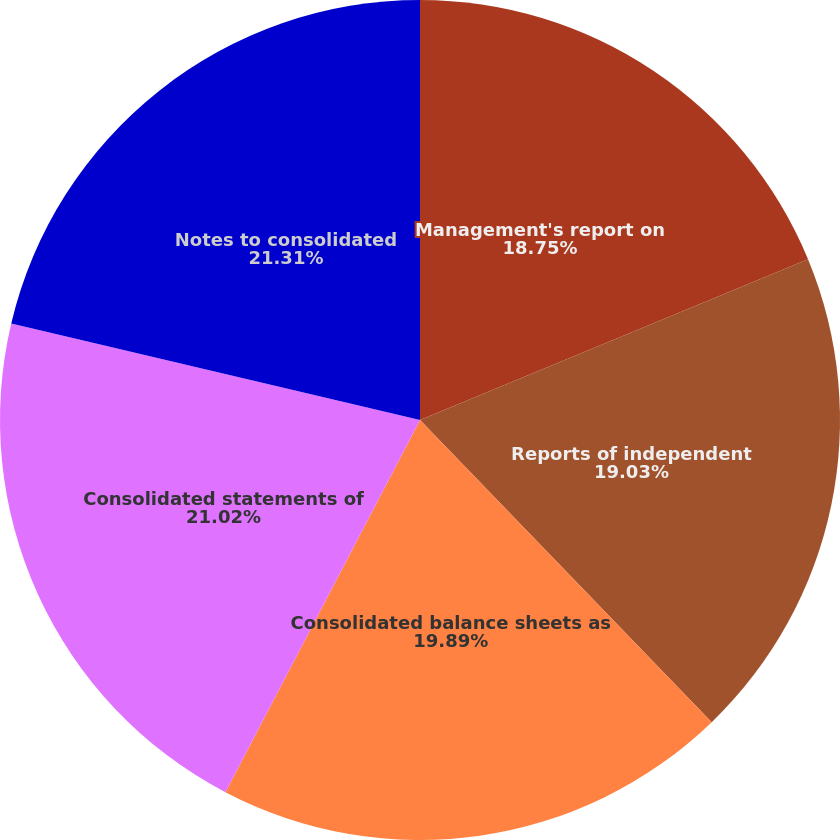Convert chart to OTSL. <chart><loc_0><loc_0><loc_500><loc_500><pie_chart><fcel>Management's report on<fcel>Reports of independent<fcel>Consolidated balance sheets as<fcel>Consolidated statements of<fcel>Notes to consolidated<nl><fcel>18.75%<fcel>19.03%<fcel>19.89%<fcel>21.02%<fcel>21.31%<nl></chart> 